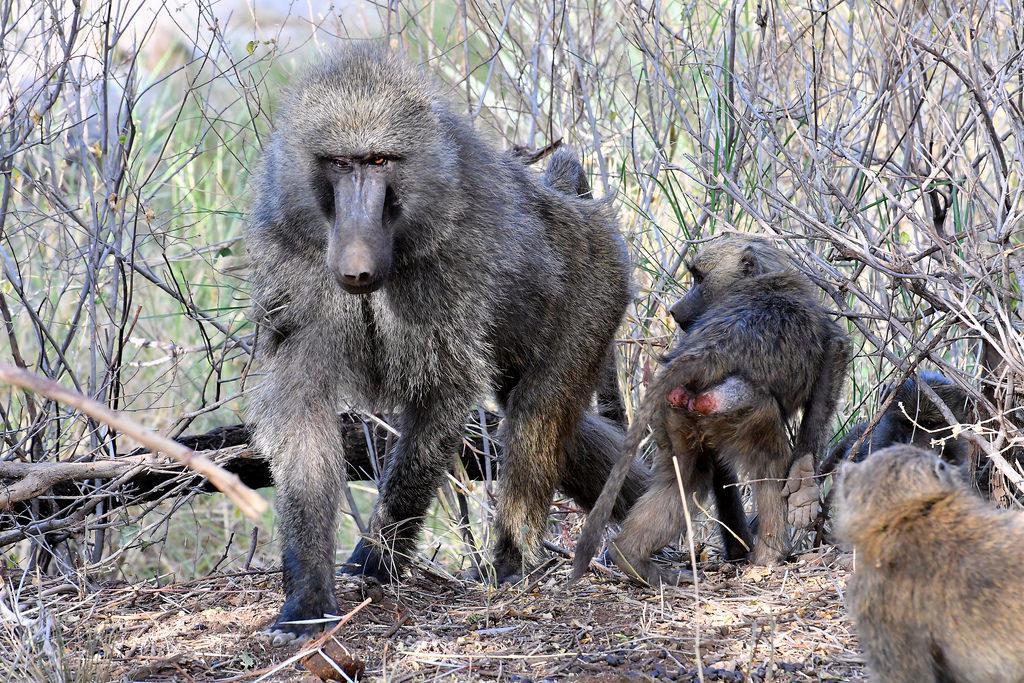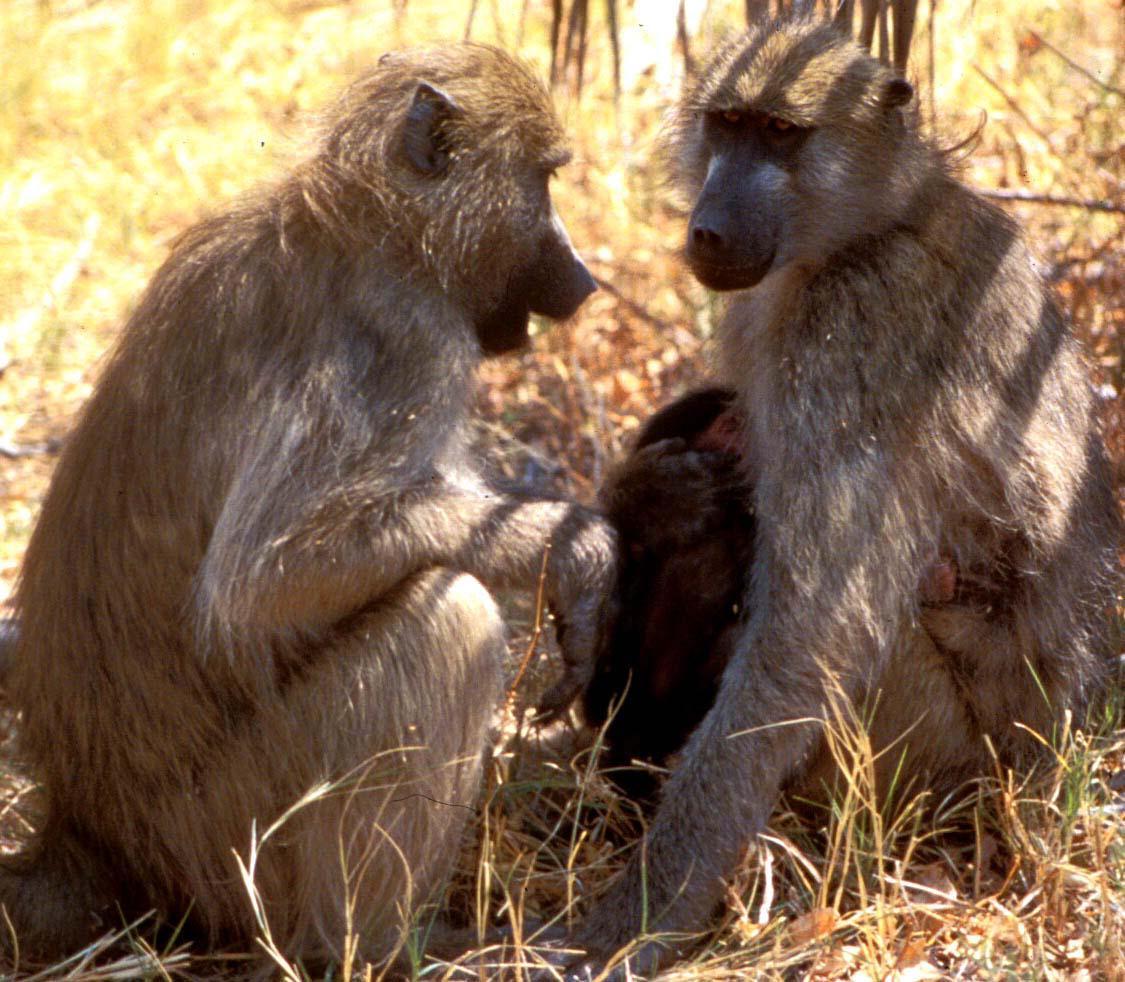The first image is the image on the left, the second image is the image on the right. Given the left and right images, does the statement "Each image contains multiple baboons but less than five baboons, and one image includes a baby baboon clinging to the chest of an adult baboon." hold true? Answer yes or no. Yes. 